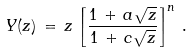<formula> <loc_0><loc_0><loc_500><loc_500>Y ( z ) \, = \, z \, \left [ \frac { 1 \, + \, a \sqrt { z } } { 1 \, + \, c \sqrt { z } } \right ] ^ { n } \, .</formula> 